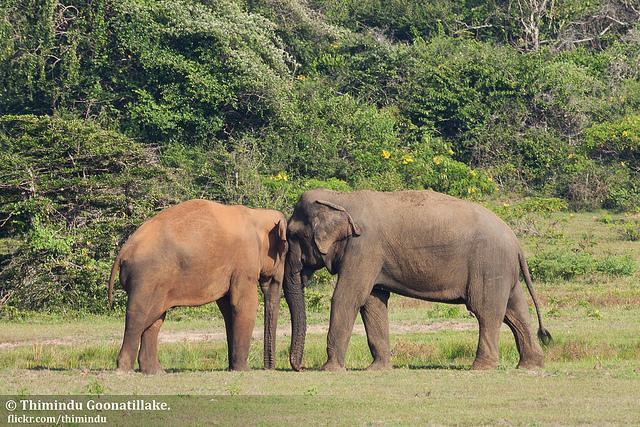How many elephants can be seen?
Give a very brief answer. 2. 